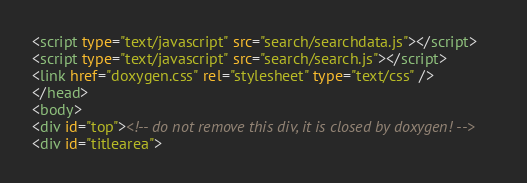Convert code to text. <code><loc_0><loc_0><loc_500><loc_500><_HTML_><script type="text/javascript" src="search/searchdata.js"></script>
<script type="text/javascript" src="search/search.js"></script>
<link href="doxygen.css" rel="stylesheet" type="text/css" />
</head>
<body>
<div id="top"><!-- do not remove this div, it is closed by doxygen! -->
<div id="titlearea"></code> 